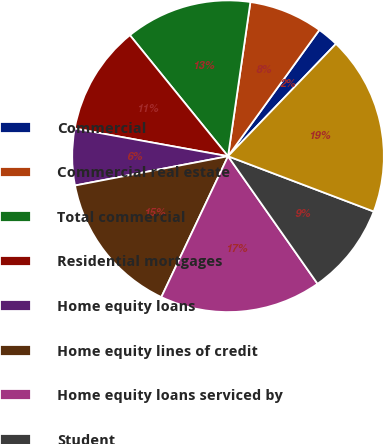<chart> <loc_0><loc_0><loc_500><loc_500><pie_chart><fcel>Commercial<fcel>Commercial real estate<fcel>Total commercial<fcel>Residential mortgages<fcel>Home equity loans<fcel>Home equity lines of credit<fcel>Home equity loans serviced by<fcel>Student<fcel>Total retail<nl><fcel>2.21%<fcel>7.67%<fcel>13.13%<fcel>11.31%<fcel>5.85%<fcel>14.95%<fcel>16.77%<fcel>9.49%<fcel>18.59%<nl></chart> 